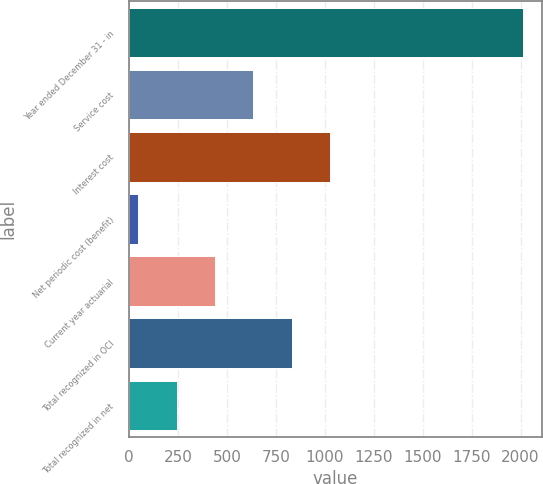<chart> <loc_0><loc_0><loc_500><loc_500><bar_chart><fcel>Year ended December 31 - in<fcel>Service cost<fcel>Interest cost<fcel>Net periodic cost (benefit)<fcel>Current year actuarial<fcel>Total recognized in OCI<fcel>Total recognized in net<nl><fcel>2010<fcel>635.2<fcel>1028<fcel>46<fcel>438.8<fcel>831.6<fcel>242.4<nl></chart> 